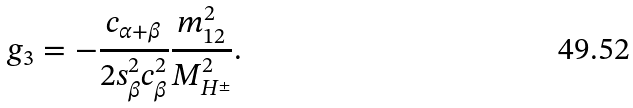Convert formula to latex. <formula><loc_0><loc_0><loc_500><loc_500>g _ { 3 } = - \frac { c _ { \alpha + \beta } } { 2 s ^ { 2 } _ { \beta } c ^ { 2 } _ { \beta } } \frac { m _ { 1 2 } ^ { 2 } } { M ^ { 2 } _ { H ^ { \pm } } } .</formula> 